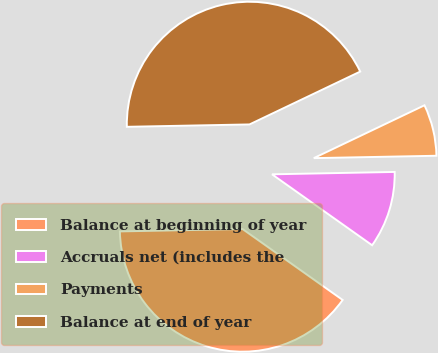<chart> <loc_0><loc_0><loc_500><loc_500><pie_chart><fcel>Balance at beginning of year<fcel>Accruals net (includes the<fcel>Payments<fcel>Balance at end of year<nl><fcel>39.88%<fcel>10.12%<fcel>6.78%<fcel>43.22%<nl></chart> 